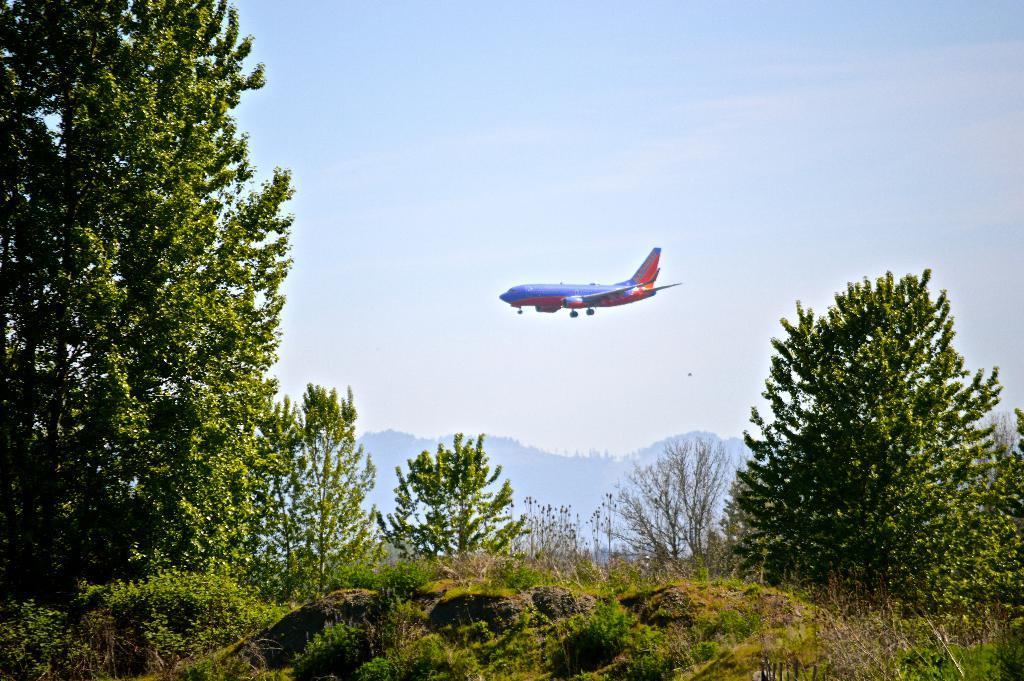Please provide a concise description of this image. In this image I can see grass, trees, mountains and an airplane. In the background I can see the sky. This image is taken may be during a day. 